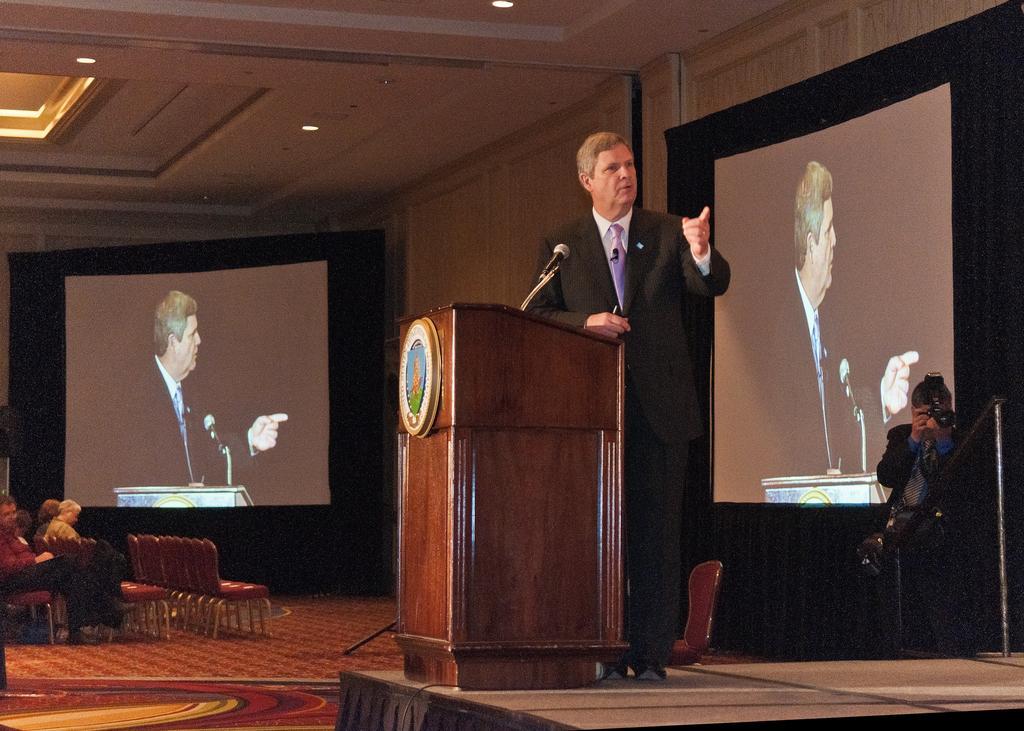How would you summarize this image in a sentence or two? In this image there is a podium, mike, in front of it there is a person standing on stage, behind him there is a screen, on which there is a person, mike,podium, in front of a podium there is a person holding a camera , pole visible on the right side, on the left side there are some chairs, on which there are some people, screen, on which there is a person, mike, podium, at the top there is the roof, on which there are some lights. 